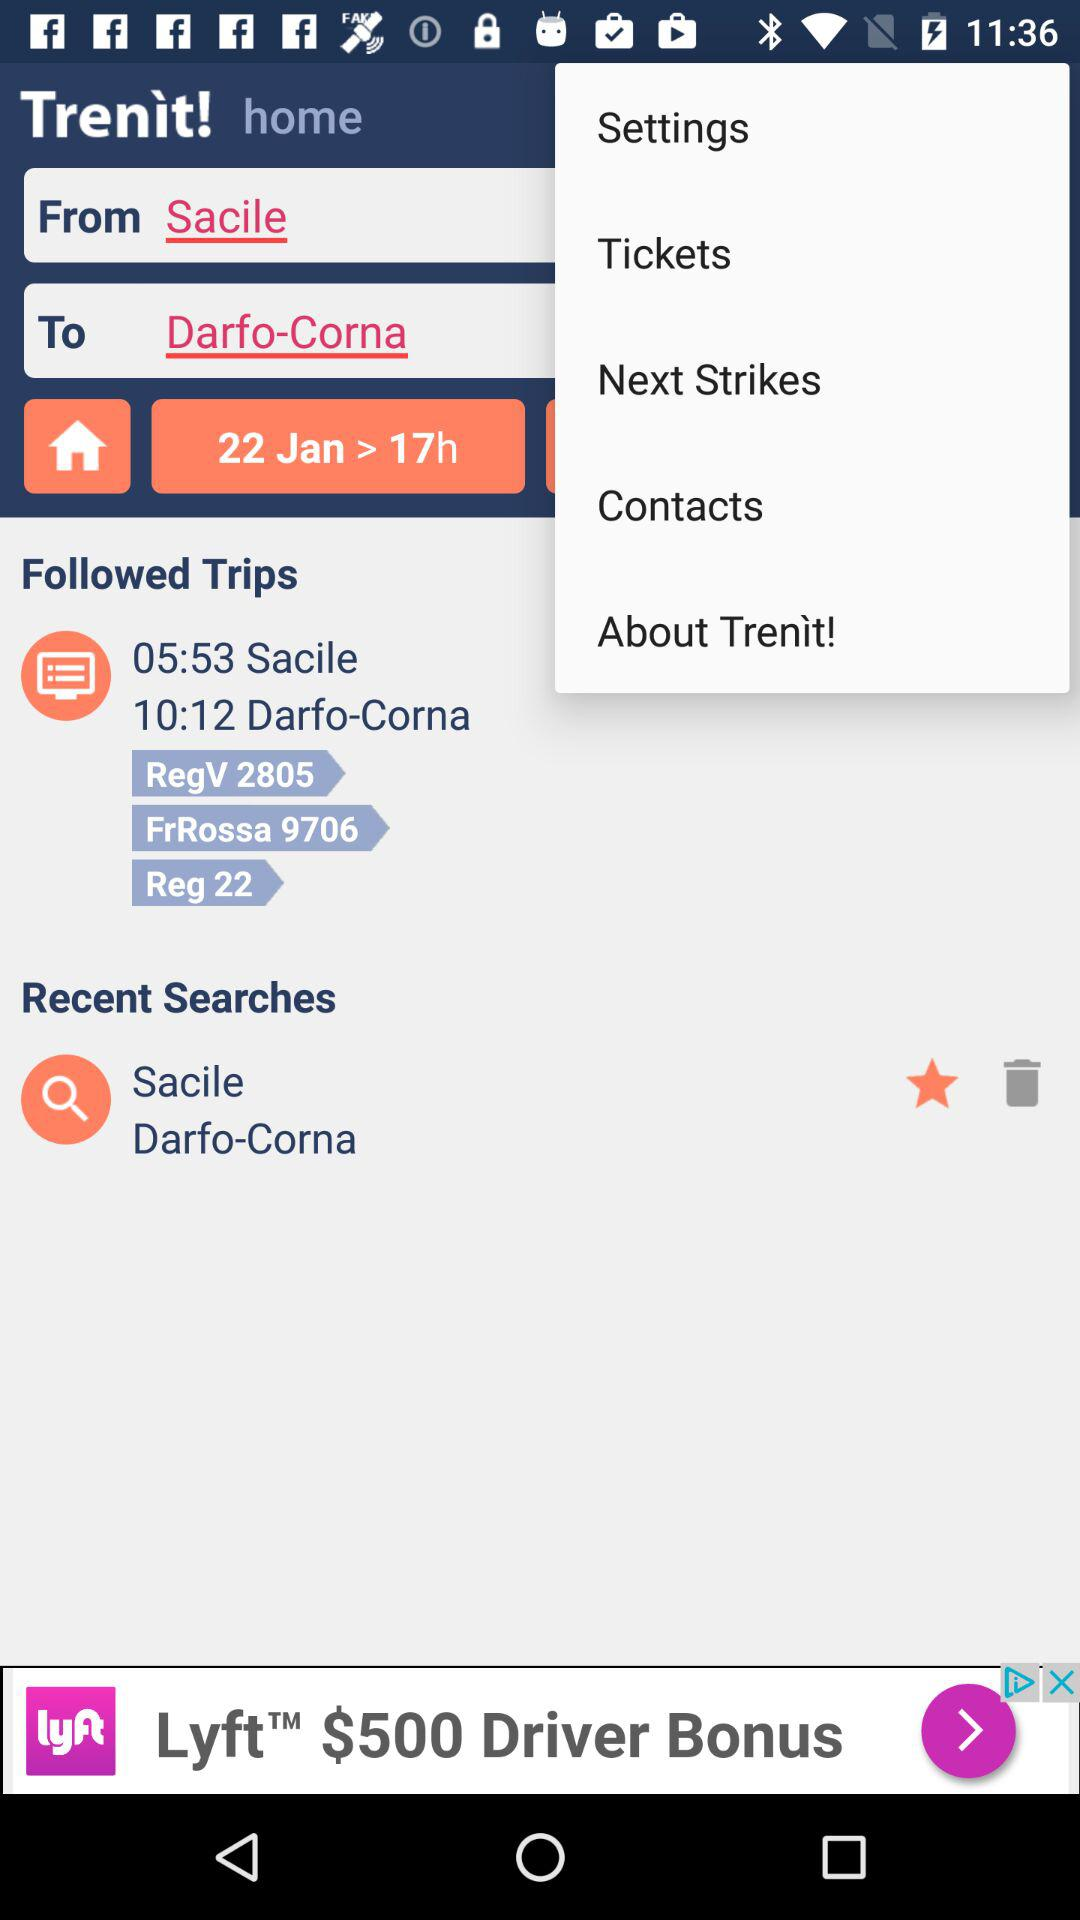What's the departure time? The departure time is 05:53. 